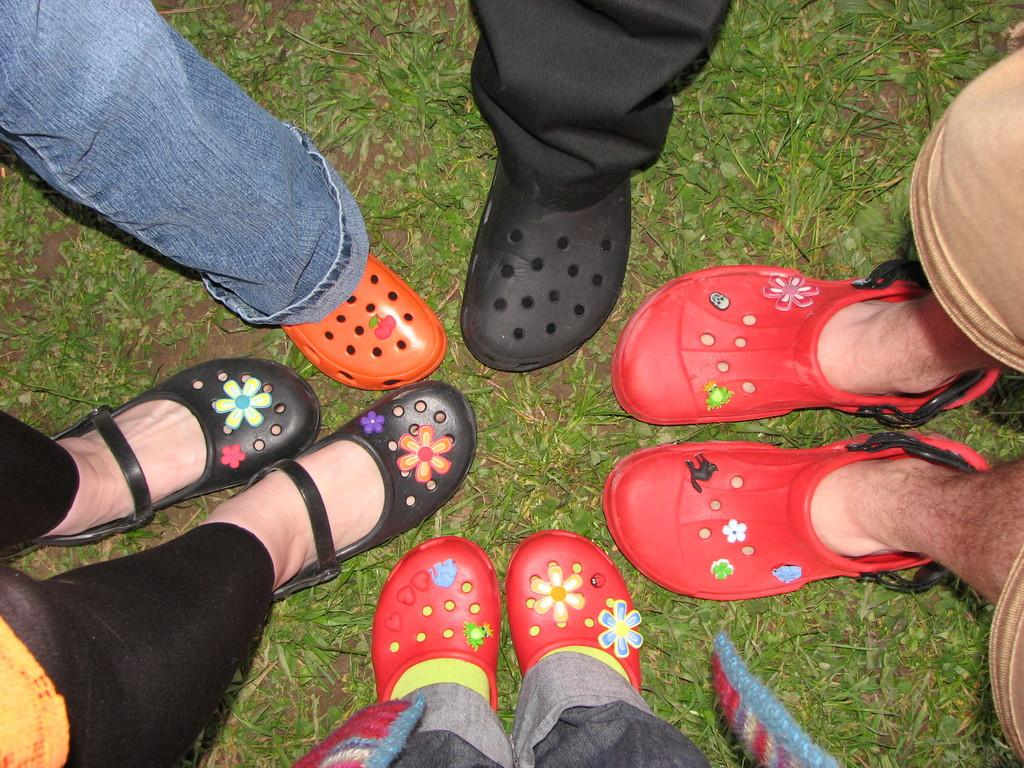What is the main subject of the image? The main subject of the image is a group of persons. What can be observed about the shoes worn by the persons in the image? The persons are wearing different colored shoes. What type of natural environment is visible in the image? There is grass visible in the image. What direction are the birds flying in the image? There are no birds present in the image. 